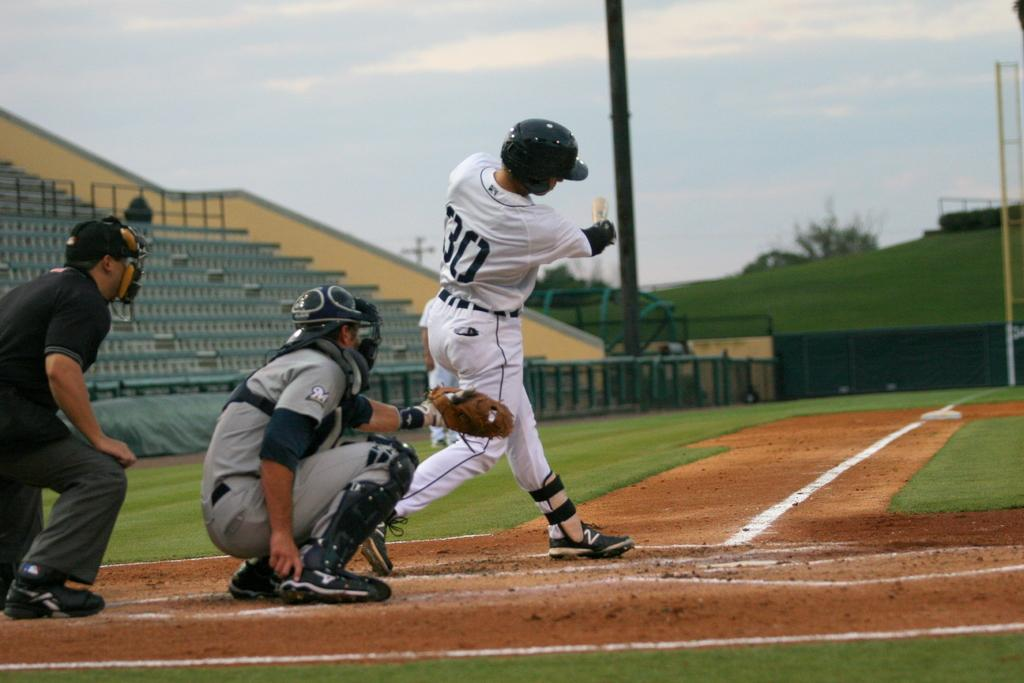<image>
Create a compact narrative representing the image presented. A baseball player at the batters plate, wearing the number 30 on the back of his jersey, has just swung the bat. 